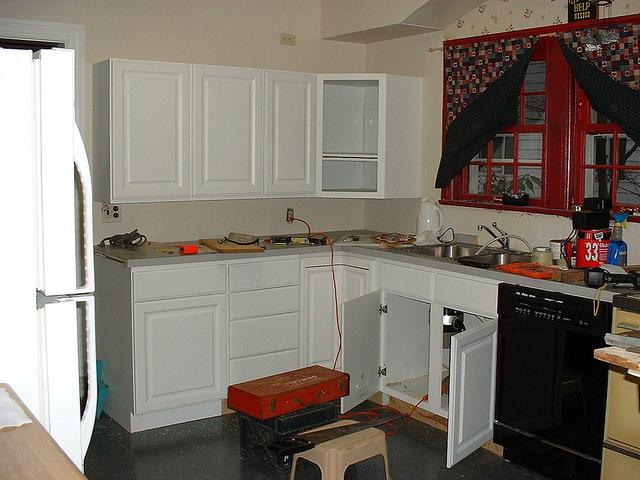Is something under the sink broken?
Be succinct. Yes. Is this kitchen clean?
Give a very brief answer. No. What type of tool is on the stool?
Answer briefly. Saw. What room is this?
Keep it brief. Kitchen. Does the room look clean?
Quick response, please. No. What pattern is on the curtain?
Answer briefly. Squares. Does this family have a pet?
Short answer required. No. What number do you see?
Write a very short answer. 33. 